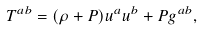<formula> <loc_0><loc_0><loc_500><loc_500>T ^ { a b } = ( \rho + P ) u ^ { a } u ^ { b } + P g ^ { a b } ,</formula> 